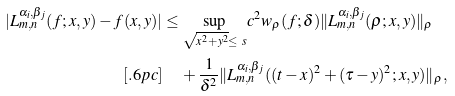<formula> <loc_0><loc_0><loc_500><loc_500>| L _ { m , n } ^ { \alpha _ { i } , \beta _ { j } } ( f ; x , y ) - f ( x , y ) | & \leq \underset { \sqrt { x ^ { 2 } + y ^ { 2 } } \leq \ s } { \sup } c ^ { 2 } w _ { \rho } ( f ; \delta ) \| L _ { m , n } ^ { \alpha _ { i } , \beta _ { j } } ( \rho ; x , y ) \| _ { \rho } \\ [ . 6 p c ] & \quad \, + \frac { 1 } { \delta ^ { 2 } } \| L _ { m , n } ^ { \alpha _ { i } , \beta _ { j } } ( ( t - x ) ^ { 2 } + ( \tau - y ) ^ { 2 } ; x , y ) \| _ { \rho } ,</formula> 